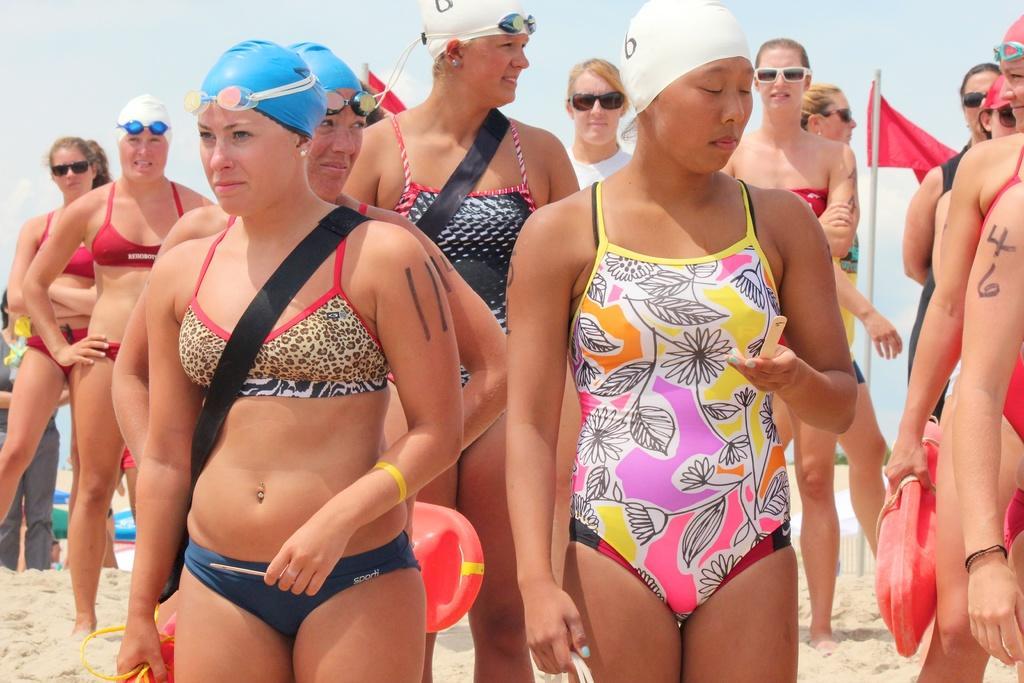Describe this image in one or two sentences. In this picture I can see number of women, who are standing and I see that all of them are wearing swimming costumes. I can also see that there are caps on few of them and rest of them are wearing shades and I see the sand. In the background I see the sky and on the right of this image I see a pole on which there is a red color flag and I see few women are holding a red color thing in their hands. 